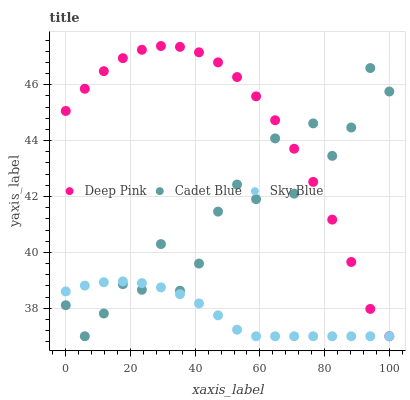Does Sky Blue have the minimum area under the curve?
Answer yes or no. Yes. Does Deep Pink have the maximum area under the curve?
Answer yes or no. Yes. Does Deep Pink have the minimum area under the curve?
Answer yes or no. No. Does Sky Blue have the maximum area under the curve?
Answer yes or no. No. Is Sky Blue the smoothest?
Answer yes or no. Yes. Is Cadet Blue the roughest?
Answer yes or no. Yes. Is Deep Pink the smoothest?
Answer yes or no. No. Is Deep Pink the roughest?
Answer yes or no. No. Does Cadet Blue have the lowest value?
Answer yes or no. Yes. Does Deep Pink have the highest value?
Answer yes or no. Yes. Does Sky Blue have the highest value?
Answer yes or no. No. Does Deep Pink intersect Sky Blue?
Answer yes or no. Yes. Is Deep Pink less than Sky Blue?
Answer yes or no. No. Is Deep Pink greater than Sky Blue?
Answer yes or no. No. 